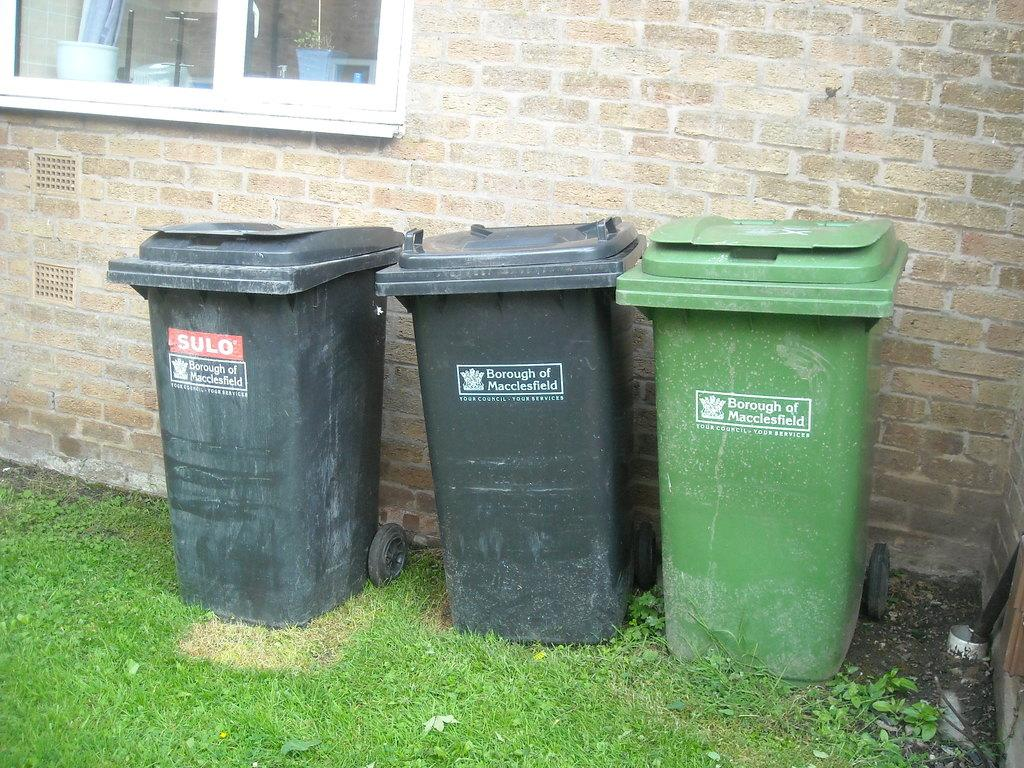<image>
Describe the image concisely. Three trash cans belonging to the borough of Macclesfield stand next to a building. 